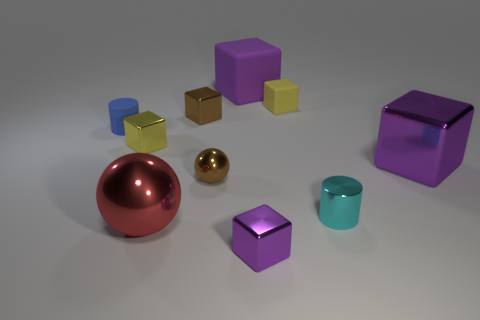There is a sphere in front of the small brown metal sphere; what size is it?
Your response must be concise. Large. Are there more shiny blocks that are in front of the purple rubber cube than large metallic spheres in front of the tiny blue matte cylinder?
Your answer should be very brief. Yes. Are the tiny purple cube and the small cylinder to the right of the big ball made of the same material?
Your answer should be compact. Yes. What is the size of the purple rubber thing that is the same shape as the yellow metallic object?
Give a very brief answer. Large. Is the number of small brown metallic spheres less than the number of tiny matte things?
Make the answer very short. Yes. Do the brown ball and the cylinder to the left of the cyan cylinder have the same size?
Your answer should be very brief. Yes. What size is the matte cylinder?
Your response must be concise. Small. Are there fewer small rubber blocks that are left of the brown cube than big yellow matte things?
Make the answer very short. No. Is the brown metallic block the same size as the blue thing?
Provide a succinct answer. Yes. There is a sphere that is made of the same material as the red thing; what color is it?
Provide a succinct answer. Brown. 